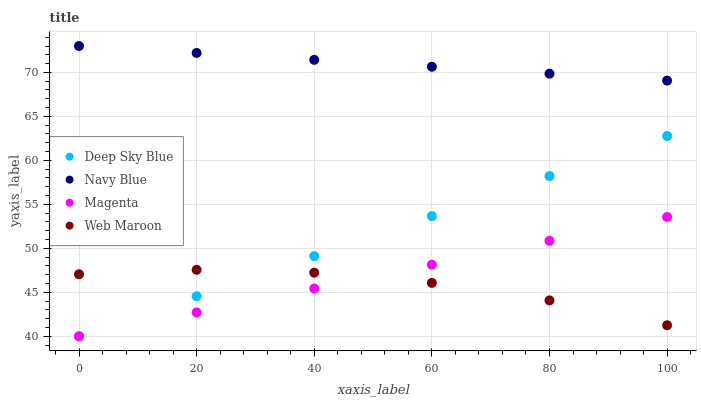Does Web Maroon have the minimum area under the curve?
Answer yes or no. Yes. Does Navy Blue have the maximum area under the curve?
Answer yes or no. Yes. Does Magenta have the minimum area under the curve?
Answer yes or no. No. Does Magenta have the maximum area under the curve?
Answer yes or no. No. Is Deep Sky Blue the smoothest?
Answer yes or no. Yes. Is Web Maroon the roughest?
Answer yes or no. Yes. Is Magenta the smoothest?
Answer yes or no. No. Is Magenta the roughest?
Answer yes or no. No. Does Magenta have the lowest value?
Answer yes or no. Yes. Does Web Maroon have the lowest value?
Answer yes or no. No. Does Navy Blue have the highest value?
Answer yes or no. Yes. Does Magenta have the highest value?
Answer yes or no. No. Is Web Maroon less than Navy Blue?
Answer yes or no. Yes. Is Navy Blue greater than Magenta?
Answer yes or no. Yes. Does Deep Sky Blue intersect Magenta?
Answer yes or no. Yes. Is Deep Sky Blue less than Magenta?
Answer yes or no. No. Is Deep Sky Blue greater than Magenta?
Answer yes or no. No. Does Web Maroon intersect Navy Blue?
Answer yes or no. No. 